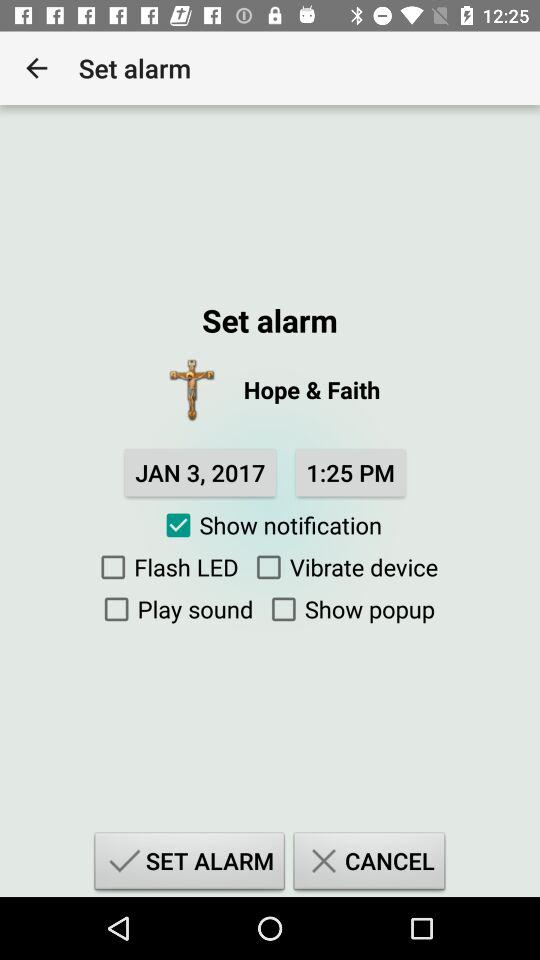Which option has been selected? The selected option is "Show notification". 